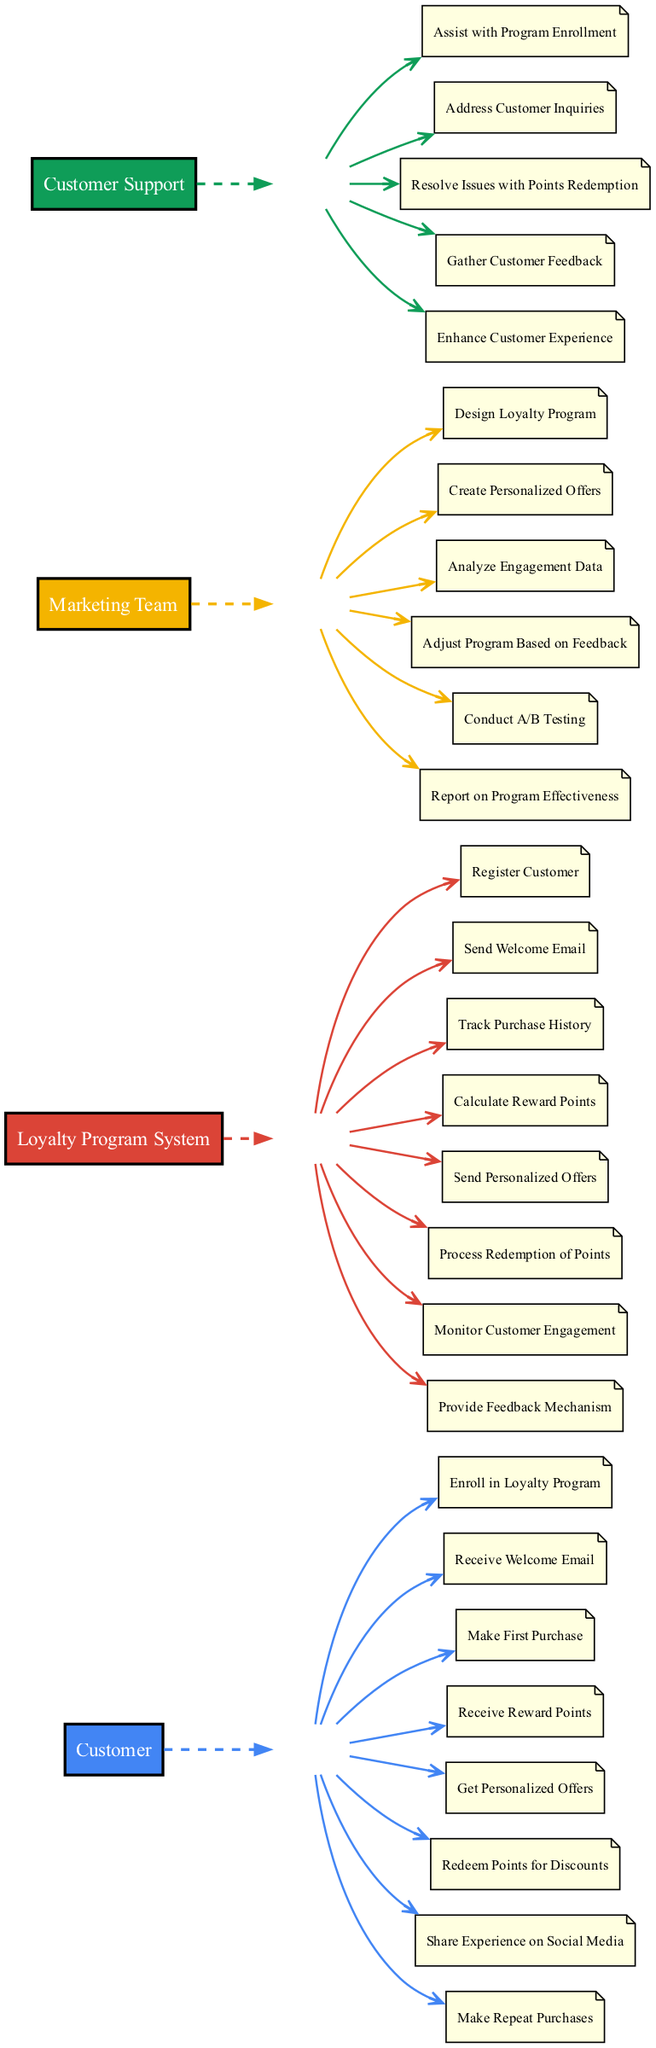What is the first action taken by the Customer? The first action in the sequence for the Customer is "Enroll in Loyalty Program," which is listed at the top of the actions for the Customer.
Answer: Enroll in Loyalty Program How many actions does the Loyalty Program System perform? The Loyalty Program System has eight actions listed, which can be counted directly from the diagram.
Answer: Eight What action does the Marketing Team take after the Customer makes their first purchase? After the first purchase, the Marketing Team creates personalized offers based on the customer's purchasing behavior and engagement, which is inferred from the connection of actions in the sequence.
Answer: Create Personalized Offers Which action directly follows "Receive Reward Points"? The action that directly follows "Receive Reward Points" for the Customer is "Get Personalized Offers," which indicates it as a subsequent action in the flow.
Answer: Get Personalized Offers Which two teams are involved in the process of analyzing engagement data? The two teams that are involved in the process of analyzing engagement data are the Marketing Team and the Loyalty Program System. This is seen as both teams track and analyze customer interactions based on the sequence of actions.
Answer: Marketing Team and Loyalty Program System What happens after the Customer shares their experience on social media? After the Customer shares their experience on social media, the Loyalty Program System monitors customer engagement, indicating a feedback loop to improve future interactions.
Answer: Monitor Customer Engagement Which action is taken by the Customer Support team regarding customer inquiries? The action taken by the Customer Support team regarding customer inquiries is "Address Customer Inquiries," which is identified in their sequence of actions.
Answer: Address Customer Inquiries What feedback mechanism is provided in the Loyalty Program System? The Loyalty Program System includes a "Provide Feedback Mechanism" as its last action to ensure customer feedback is collected to improve the program.
Answer: Provide Feedback Mechanism 